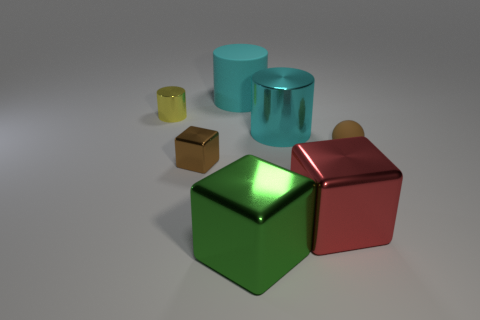Add 2 yellow shiny cylinders. How many objects exist? 9 Subtract all cubes. How many objects are left? 4 Add 7 metal cylinders. How many metal cylinders are left? 9 Add 7 cylinders. How many cylinders exist? 10 Subtract 0 cyan blocks. How many objects are left? 7 Subtract all big green blocks. Subtract all small brown rubber balls. How many objects are left? 5 